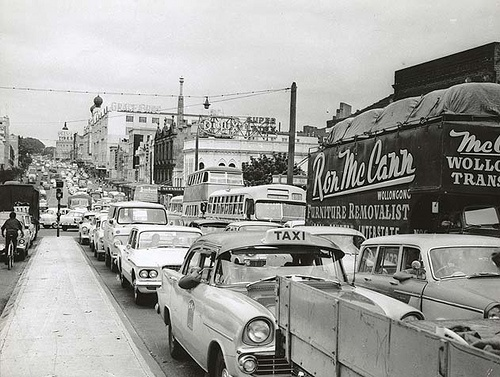Describe the objects in this image and their specific colors. I can see truck in lightgray, black, darkgray, and gray tones, truck in lightgray, darkgray, gray, and black tones, car in lightgray, darkgray, black, and gray tones, car in lightgray, darkgray, gray, and black tones, and car in lightgray, darkgray, gray, and black tones in this image. 